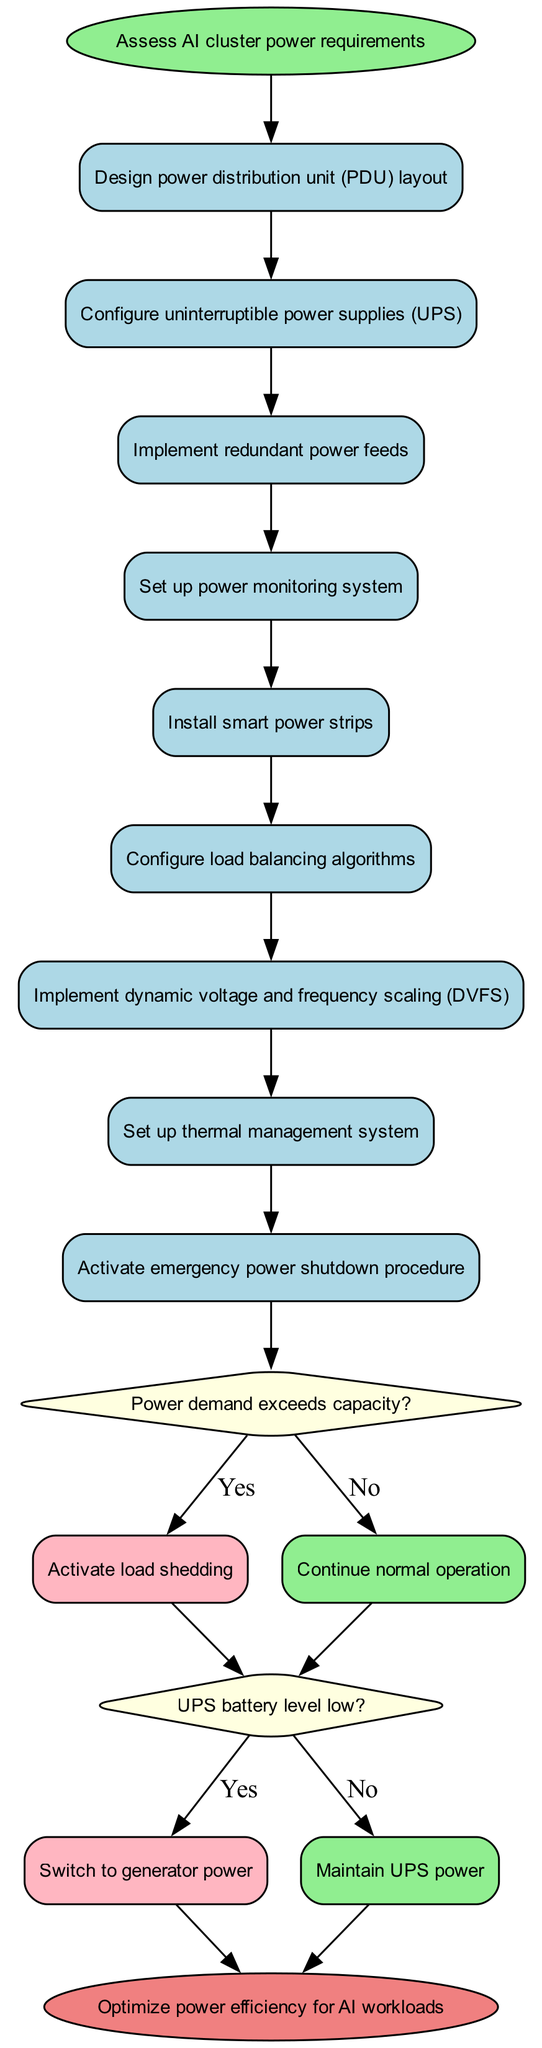What is the starting node of the diagram? The starting node is explicitly labeled in the diagram as "Assess AI cluster power requirements," indicating that this is the initial activity to be performed in the flow.
Answer: Assess AI cluster power requirements How many activities are present in the diagram? The diagram lists a total of nine activities, which can be counted from the activities section in the provided data.
Answer: 9 What action is taken if the UPS battery level is low? According to the decision node related to UPS battery levels, if the battery level is low, the action taken is to "Switch to generator power."
Answer: Switch to generator power What follows after the decision on power demand? After evaluating whether the power demand exceeds capacity, if the answer is 'Yes', the next action specified in the diagram is to "Activate load shedding." This shows the consequence of that decision.
Answer: Activate load shedding Which system is set up to manage thermal conditions? The diagram specifies the activity "Set up thermal management system," indicating the activity focused on managing heat within the power system for the AI clusters.
Answer: Set up thermal management system What happens if the power demand does not exceed capacity? If the power demand does not exceed capacity, the flow continues to "Continue normal operation," indicating no immediate action is required in that scenario.
Answer: Continue normal operation Which decision follows the last activity in the series? The last activity in the series is "Implement dynamic voltage and frequency scaling (DVFS)," which leads directly to the decision node regarding power demand.
Answer: Power demand exceeds capacity? What is the end node of this diagram? The end node is clearly defined in the diagram as "Optimize power efficiency for AI workloads," indicating the goal of the process after all activities and decisions.
Answer: Optimize power efficiency for AI workloads What reveals the next step in the event of normal operation? The decision related to power demand indicates that when there's normal operation, the flow continues to the next decision prompt regarding UPS battery level.
Answer: Decision on UPS battery level 